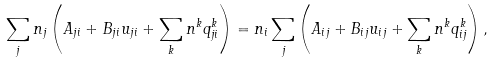Convert formula to latex. <formula><loc_0><loc_0><loc_500><loc_500>\sum _ { j } n _ { j } \left ( A _ { j i } + B _ { j i } u _ { j i } + \sum _ { k } n ^ { k } q ^ { k } _ { j i } \right ) = n _ { i } \sum _ { j } \left ( A _ { i j } + B _ { i j } u _ { i j } + \sum _ { k } n ^ { k } q ^ { k } _ { i j } \right ) ,</formula> 